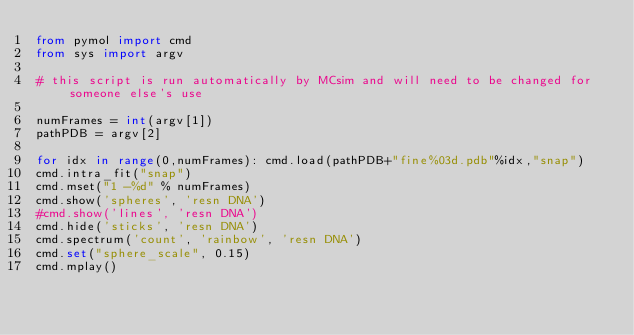<code> <loc_0><loc_0><loc_500><loc_500><_Python_>from pymol import cmd
from sys import argv

# this script is run automatically by MCsim and will need to be changed for someone else's use

numFrames = int(argv[1])
pathPDB = argv[2]

for idx in range(0,numFrames): cmd.load(pathPDB+"fine%03d.pdb"%idx,"snap")
cmd.intra_fit("snap")
cmd.mset("1 -%d" % numFrames)
cmd.show('spheres', 'resn DNA')
#cmd.show('lines', 'resn DNA')
cmd.hide('sticks', 'resn DNA')
cmd.spectrum('count', 'rainbow', 'resn DNA')
cmd.set("sphere_scale", 0.15)
cmd.mplay()
</code> 